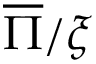Convert formula to latex. <formula><loc_0><loc_0><loc_500><loc_500>\overline { \Pi } / \xi</formula> 